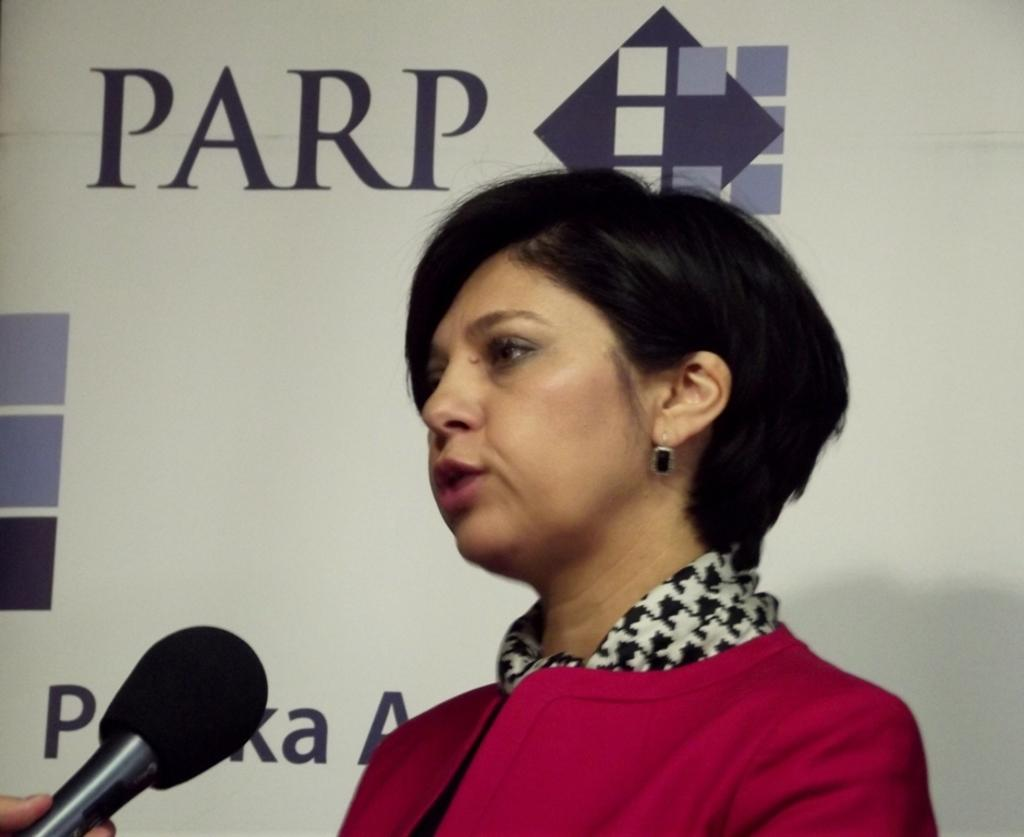Who is the main subject in the image? There is a lady in the center of the image. What is the lady holding in the image? There is no indication that the lady is holding anything in the image. What can be seen in the background of the image? There is a board in the background of the image. What is written or displayed on the board? There is text visible on the board, and there are logos visible as well. Is there any blood visible on the lady's clothing in the image? There is no mention of blood or any indication that it is present in the image. 